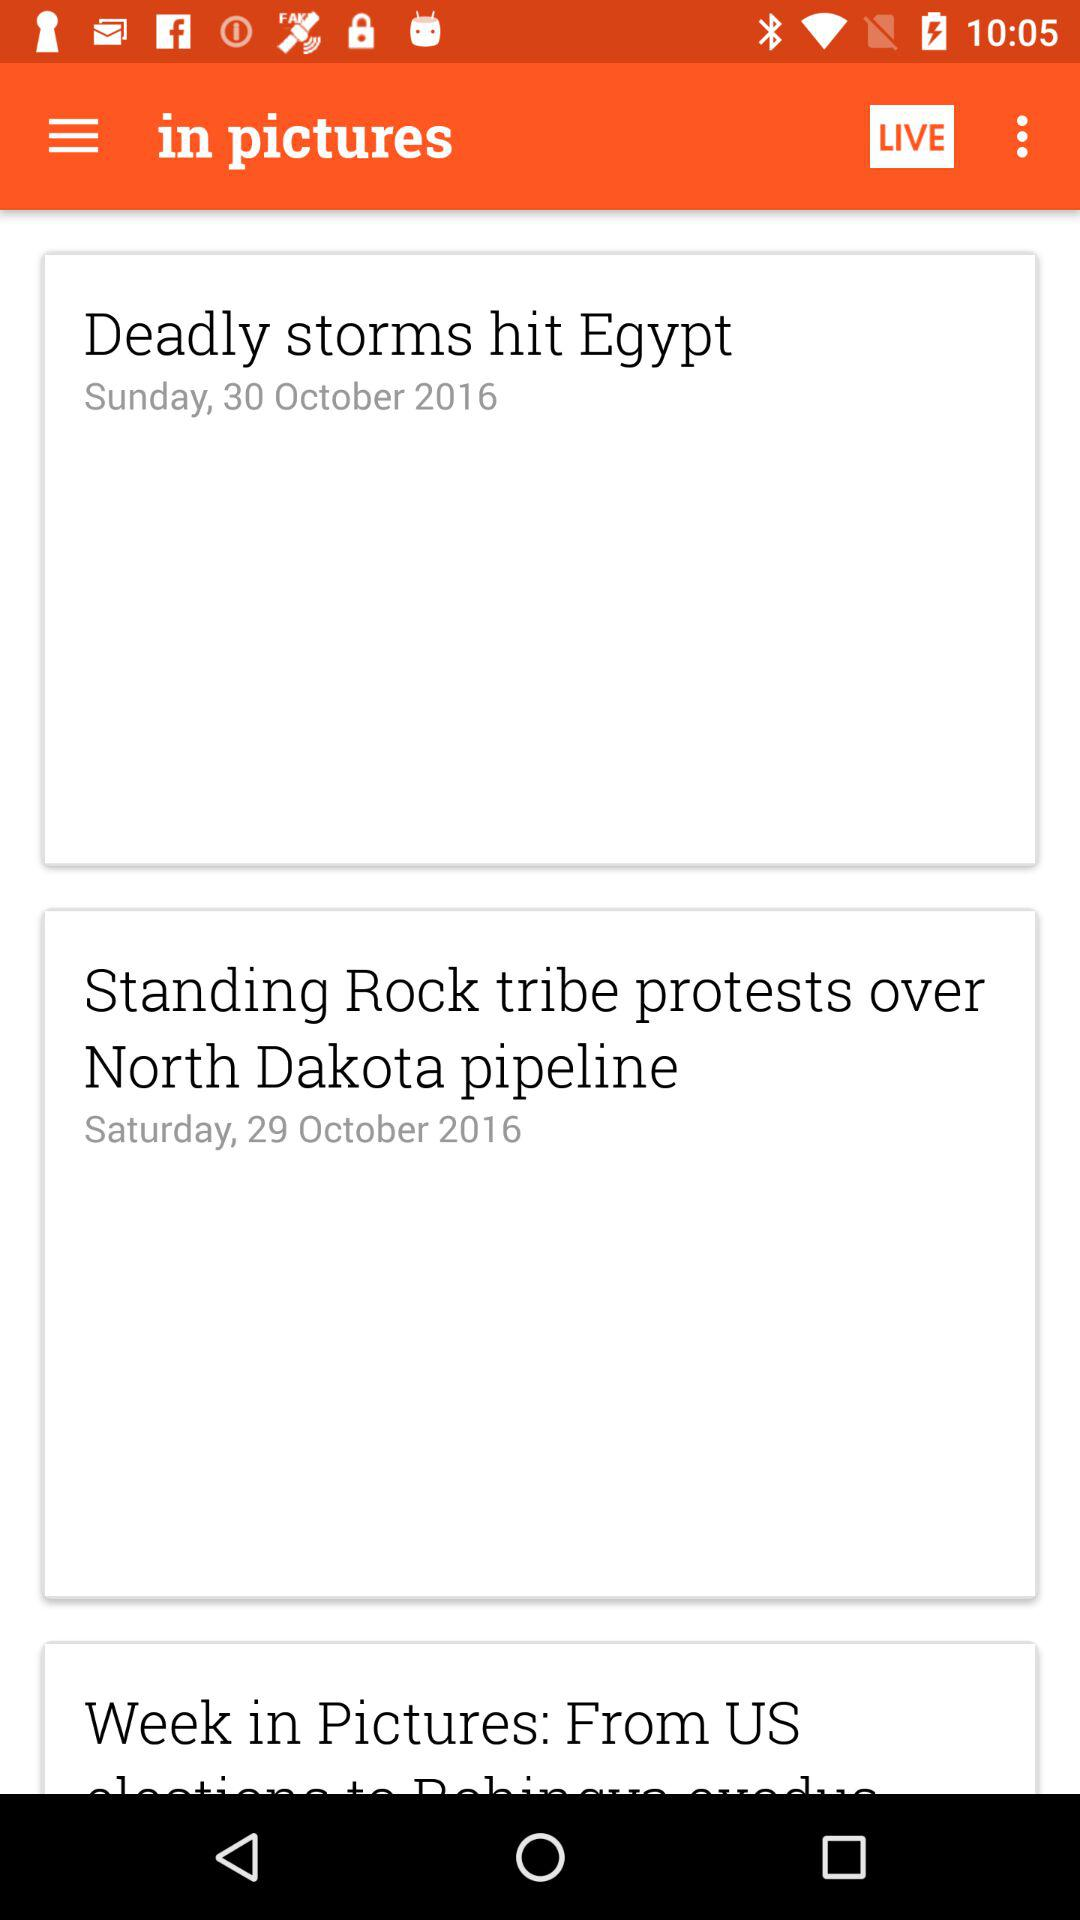What day is it on October 30, 2016? The day is Sunday. 